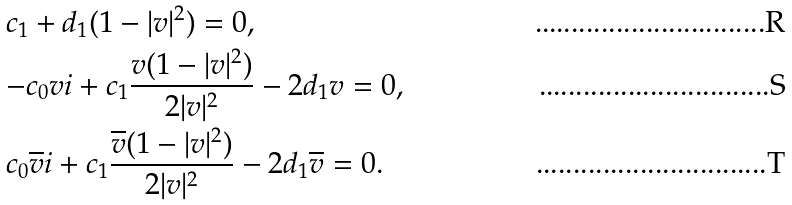Convert formula to latex. <formula><loc_0><loc_0><loc_500><loc_500>& c _ { 1 } + d _ { 1 } ( 1 - | v | ^ { 2 } ) = 0 , \\ & { - c _ { 0 } v { i } } + c _ { 1 } \frac { v ( 1 - | v | ^ { 2 } ) } { 2 | v | ^ { 2 } } - 2 d _ { 1 } v = 0 , \\ & { c _ { 0 } \overline { v } { i } } + c _ { 1 } \frac { \overline { v } ( 1 - | v | ^ { 2 } ) } { 2 | v | ^ { 2 } } - 2 d _ { 1 } \overline { v } = 0 .</formula> 